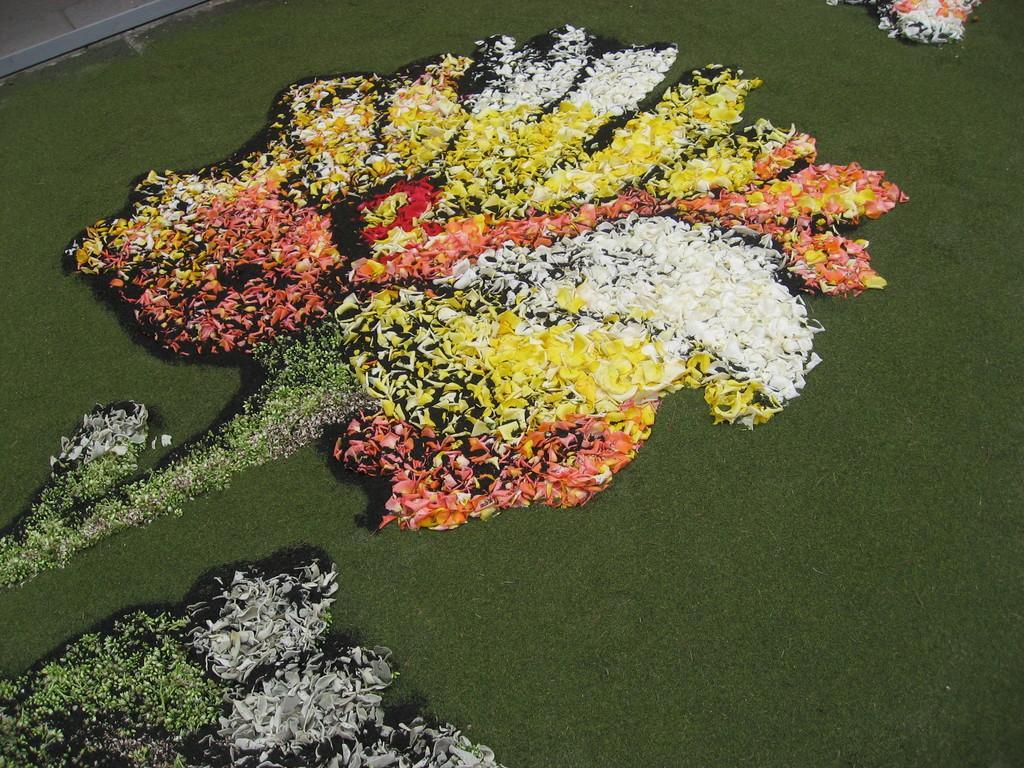Can you describe this image briefly? In the picture we can see a green color mat on it we can see a flower shaped decoration with flower petals which are yellow, white, orange, and green in color. 